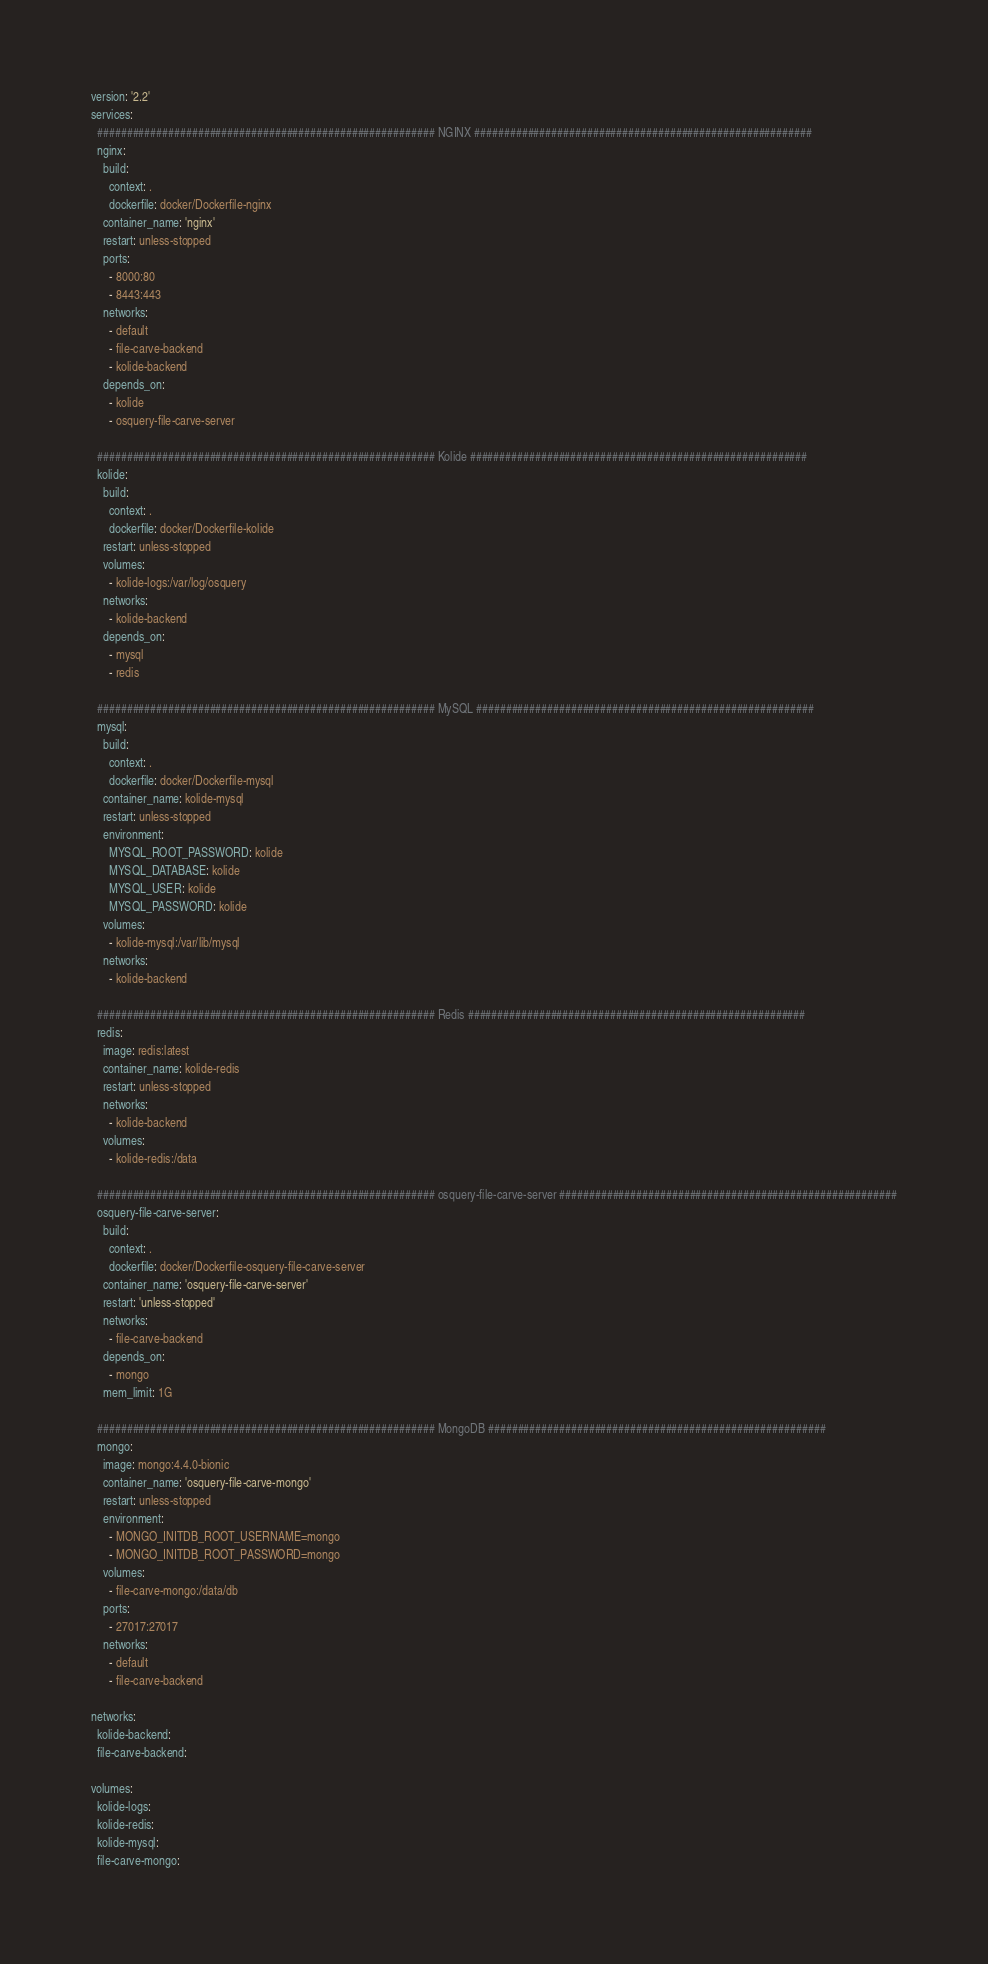Convert code to text. <code><loc_0><loc_0><loc_500><loc_500><_YAML_>version: '2.2'
services: 
  ######################################################### NGINX #########################################################
  nginx:
    build: 
      context: .
      dockerfile: docker/Dockerfile-nginx
    container_name: 'nginx'
    restart: unless-stopped
    ports: 
      - 8000:80
      - 8443:443
    networks: 
      - default
      - file-carve-backend
      - kolide-backend
    depends_on: 
      - kolide
      - osquery-file-carve-server

  ######################################################### Kolide #########################################################
  kolide:
    build: 
      context: .
      dockerfile: docker/Dockerfile-kolide
    restart: unless-stopped
    volumes: 
      - kolide-logs:/var/log/osquery
    networks: 
      - kolide-backend
    depends_on:
      - mysql
      - redis
  
  ######################################################### MySQL #########################################################
  mysql:
    build: 
      context: .
      dockerfile: docker/Dockerfile-mysql
    container_name: kolide-mysql
    restart: unless-stopped
    environment: 
      MYSQL_ROOT_PASSWORD: kolide
      MYSQL_DATABASE: kolide
      MYSQL_USER: kolide
      MYSQL_PASSWORD: kolide
    volumes: 
      - kolide-mysql:/var/lib/mysql
    networks: 
      - kolide-backend

  ######################################################### Redis #########################################################
  redis:
    image: redis:latest
    container_name: kolide-redis
    restart: unless-stopped
    networks: 
      - kolide-backend 
    volumes: 
      - kolide-redis:/data

  ######################################################### osquery-file-carve-server #########################################################
  osquery-file-carve-server:
    build: 
      context: .
      dockerfile: docker/Dockerfile-osquery-file-carve-server
    container_name: 'osquery-file-carve-server'
    restart: 'unless-stopped'
    networks: 
      - file-carve-backend
    depends_on: 
      - mongo
    mem_limit: 1G

  ######################################################### MongoDB #########################################################
  mongo:
    image: mongo:4.4.0-bionic
    container_name: 'osquery-file-carve-mongo'
    restart: unless-stopped
    environment: 
      - MONGO_INITDB_ROOT_USERNAME=mongo
      - MONGO_INITDB_ROOT_PASSWORD=mongo
    volumes:  
      - file-carve-mongo:/data/db
    ports:
      - 27017:27017
    networks: 
      - default
      - file-carve-backend

networks:
  kolide-backend:
  file-carve-backend:

volumes: 
  kolide-logs:
  kolide-redis:
  kolide-mysql:
  file-carve-mongo:</code> 